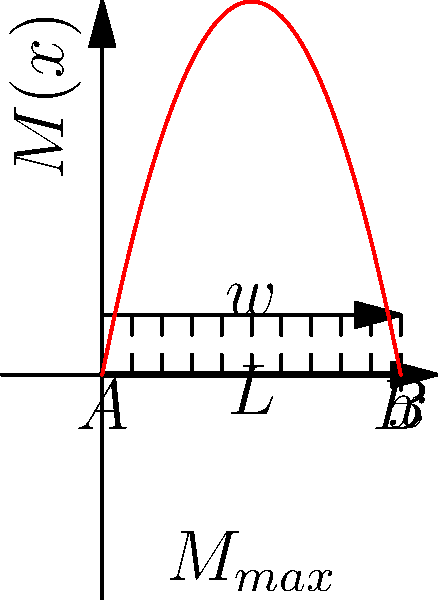Consider a simply supported beam of length $L = 10$ m with a uniformly distributed load $w = 2$ kN/m along its entire length. Determine the maximum bending moment $M_{max}$ and its location $x$ along the beam. Express your answer in terms of $wL^2$. To solve this problem, let's follow these steps:

1) The bending moment equation for a simply supported beam with a uniformly distributed load is:

   $$M(x) = \frac{wx}{2}(L-x)$$

   where $x$ is the distance from the left support.

2) To find the maximum bending moment, we need to find the point where $\frac{dM}{dx} = 0$:

   $$\frac{dM}{dx} = \frac{w}{2}(L-x) - \frac{wx}{2} = \frac{w}{2}(L-2x)$$

3) Setting this equal to zero:

   $$\frac{w}{2}(L-2x) = 0$$
   $$L-2x = 0$$
   $$x = \frac{L}{2}$$

4) This shows that the maximum bending moment occurs at the middle of the beam.

5) To find the maximum bending moment, we substitute $x = \frac{L}{2}$ into the original equation:

   $$M_{max} = M(\frac{L}{2}) = \frac{w(\frac{L}{2})}{2}(L-\frac{L}{2}) = \frac{wL}{4} \cdot \frac{L}{2} = \frac{wL^2}{8}$$

6) Substituting the given values ($w = 2$ kN/m, $L = 10$ m):

   $$M_{max} = \frac{2 \cdot 10^2}{8} = 25 \text{ kN·m} = \frac{1}{8}wL^2$$

Therefore, the maximum bending moment is $\frac{1}{8}wL^2$ and it occurs at $x = \frac{L}{2}$.
Answer: $M_{max} = \frac{1}{8}wL^2$ at $x = \frac{L}{2}$ 